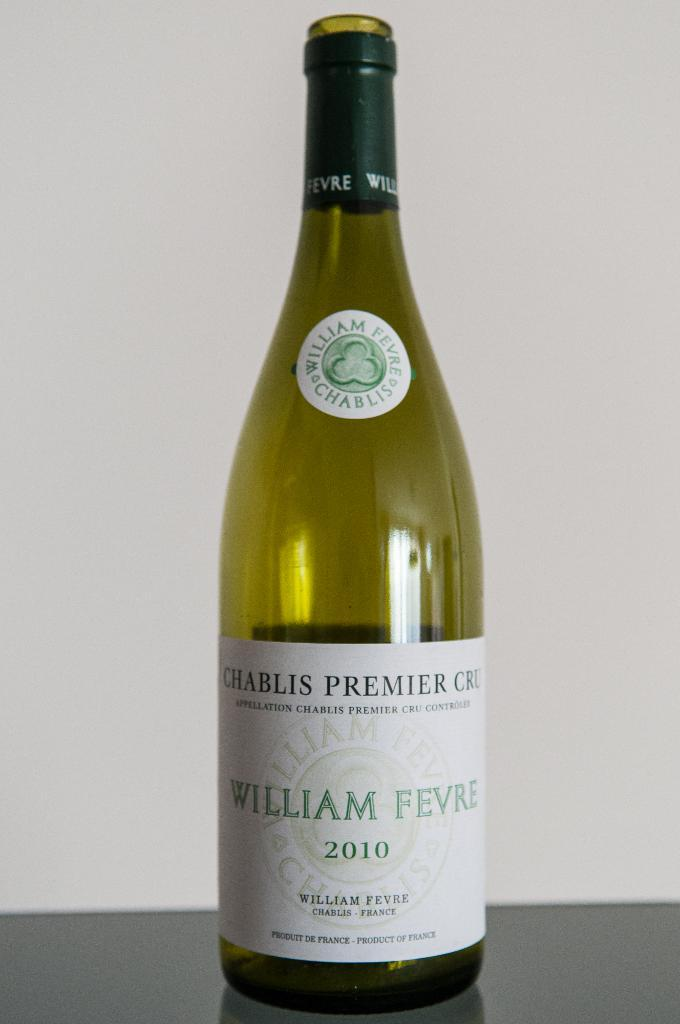<image>
Provide a brief description of the given image. An emtpy 2010 bottle of William Fevre chablis premier cru. 